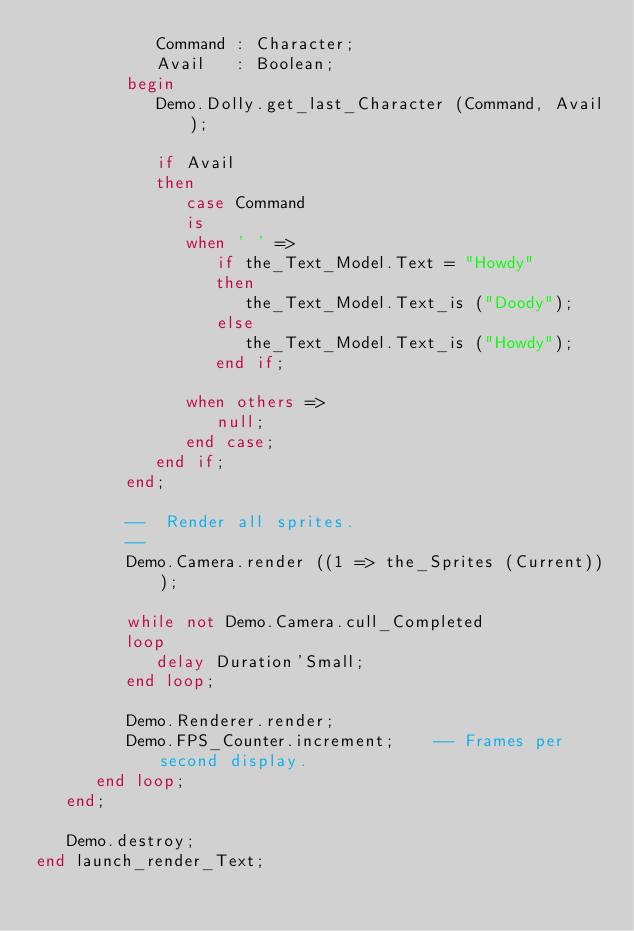Convert code to text. <code><loc_0><loc_0><loc_500><loc_500><_Ada_>            Command : Character;
            Avail   : Boolean;
         begin
            Demo.Dolly.get_last_Character (Command, Avail);

            if Avail
            then
               case Command
               is
               when ' ' =>
                  if the_Text_Model.Text = "Howdy"
                  then
                     the_Text_Model.Text_is ("Doody");
                  else
                     the_Text_Model.Text_is ("Howdy");
                  end if;

               when others =>
                  null;
               end case;
            end if;
         end;

         --  Render all sprites.
         --
         Demo.Camera.render ((1 => the_Sprites (Current)));

         while not Demo.Camera.cull_Completed
         loop
            delay Duration'Small;
         end loop;

         Demo.Renderer.render;
         Demo.FPS_Counter.increment;    -- Frames per second display.
      end loop;
   end;

   Demo.destroy;
end launch_render_Text;
</code> 